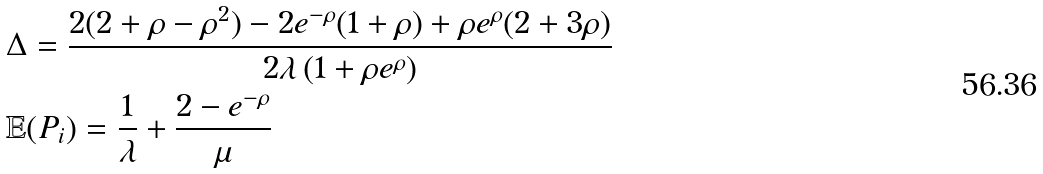Convert formula to latex. <formula><loc_0><loc_0><loc_500><loc_500>& \Delta = \frac { 2 ( 2 + \rho - \rho ^ { 2 } ) - 2 e ^ { - \rho } ( 1 + \rho ) + \rho e ^ { \rho } ( 2 + 3 \rho ) } { 2 \lambda \left ( 1 + \rho e ^ { \rho } \right ) } \\ & \mathbb { E } ( P _ { i } ) = \frac { 1 } { \lambda } + \frac { 2 - e ^ { - \rho } } { \mu }</formula> 